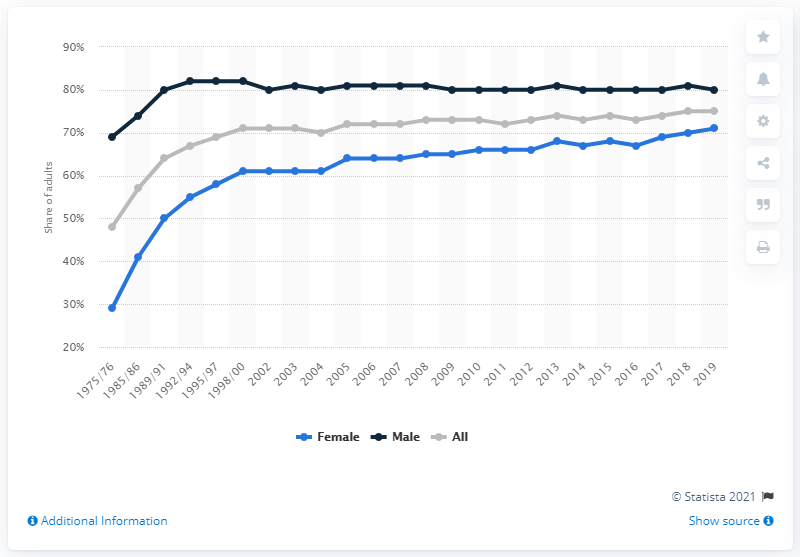Mention a couple of crucial points in this snapshot. Since the year 2002, the percentage of all adults carrying driving licenses has remained stable. 